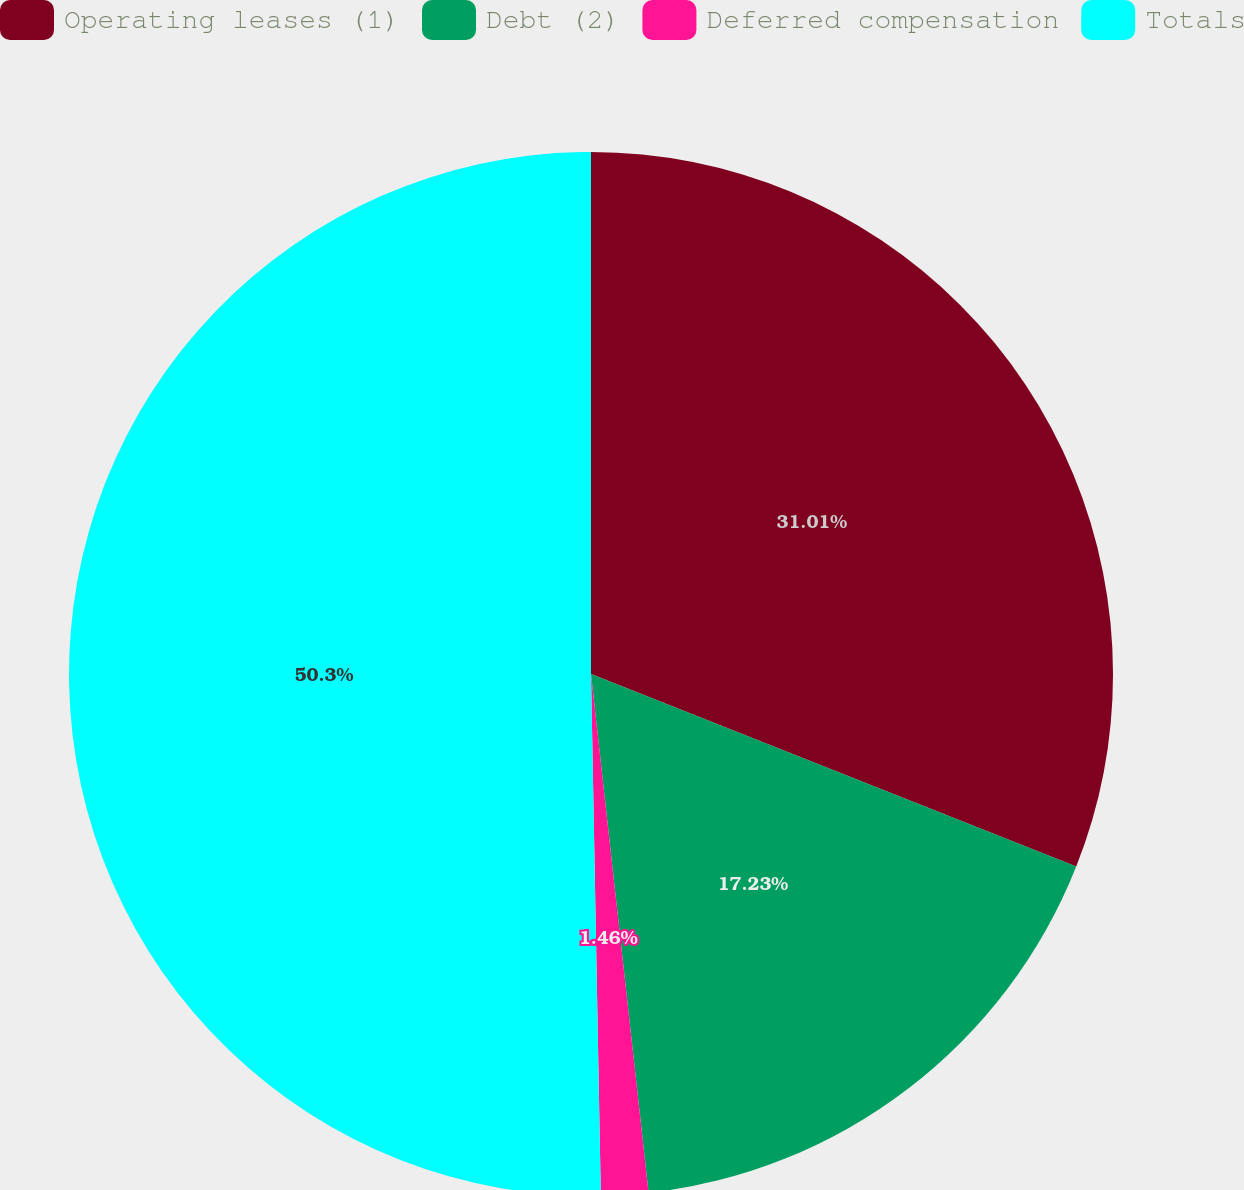Convert chart to OTSL. <chart><loc_0><loc_0><loc_500><loc_500><pie_chart><fcel>Operating leases (1)<fcel>Debt (2)<fcel>Deferred compensation<fcel>Totals<nl><fcel>31.01%<fcel>17.23%<fcel>1.46%<fcel>50.3%<nl></chart> 